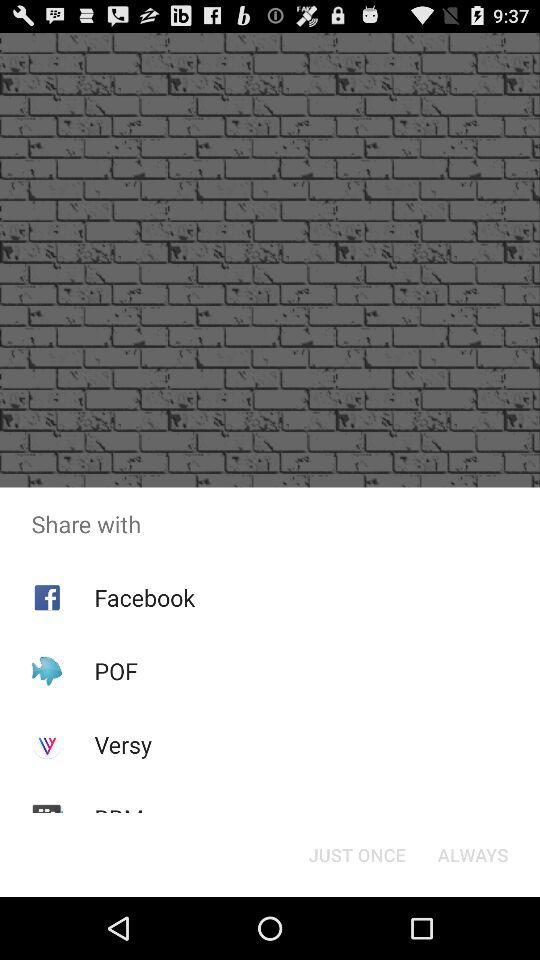Which application is selected to share the content?
When the provided information is insufficient, respond with <no answer>. <no answer> 